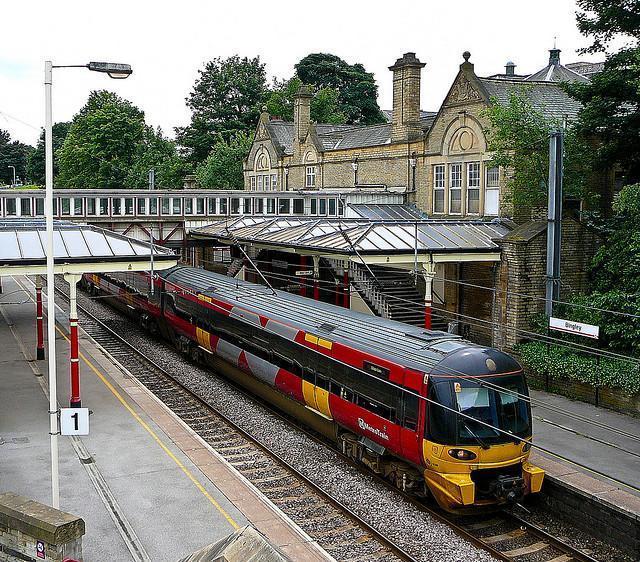How many cats have a banana in their paws?
Give a very brief answer. 0. 